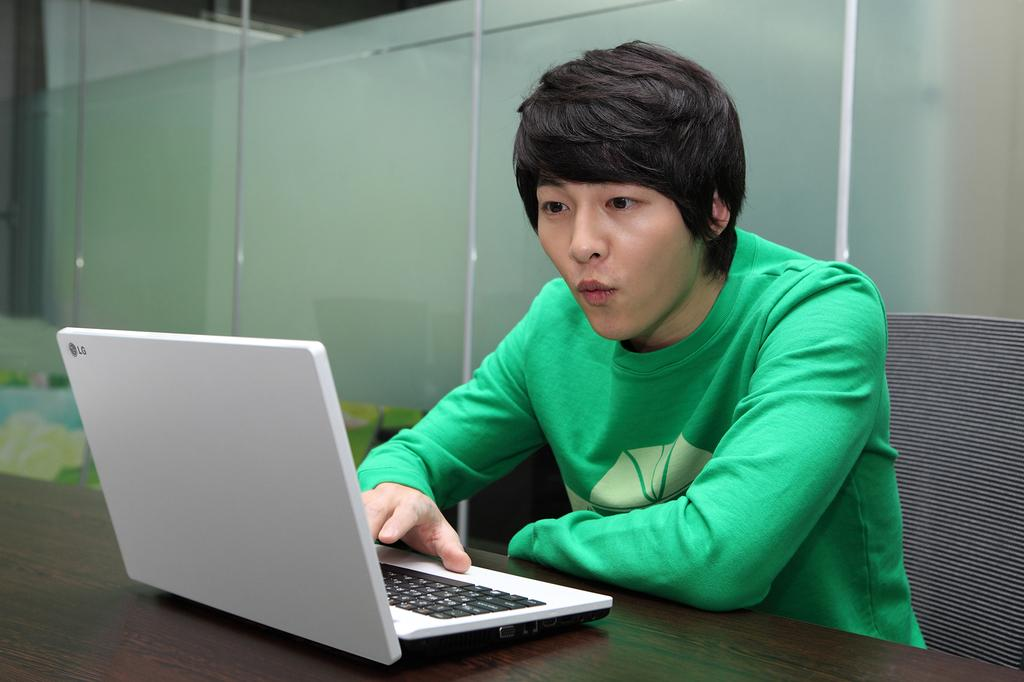What is the main subject of the image? There is a man sitting in the center of the image. What is in front of the man? There is a table in front of the man. What is placed on the table? A laptop is placed on the table. What can be seen in the background of the image? There is a glass wall in the background of the image. What type of structure does the owl build in the image? There is no owl or structure present in the image. 